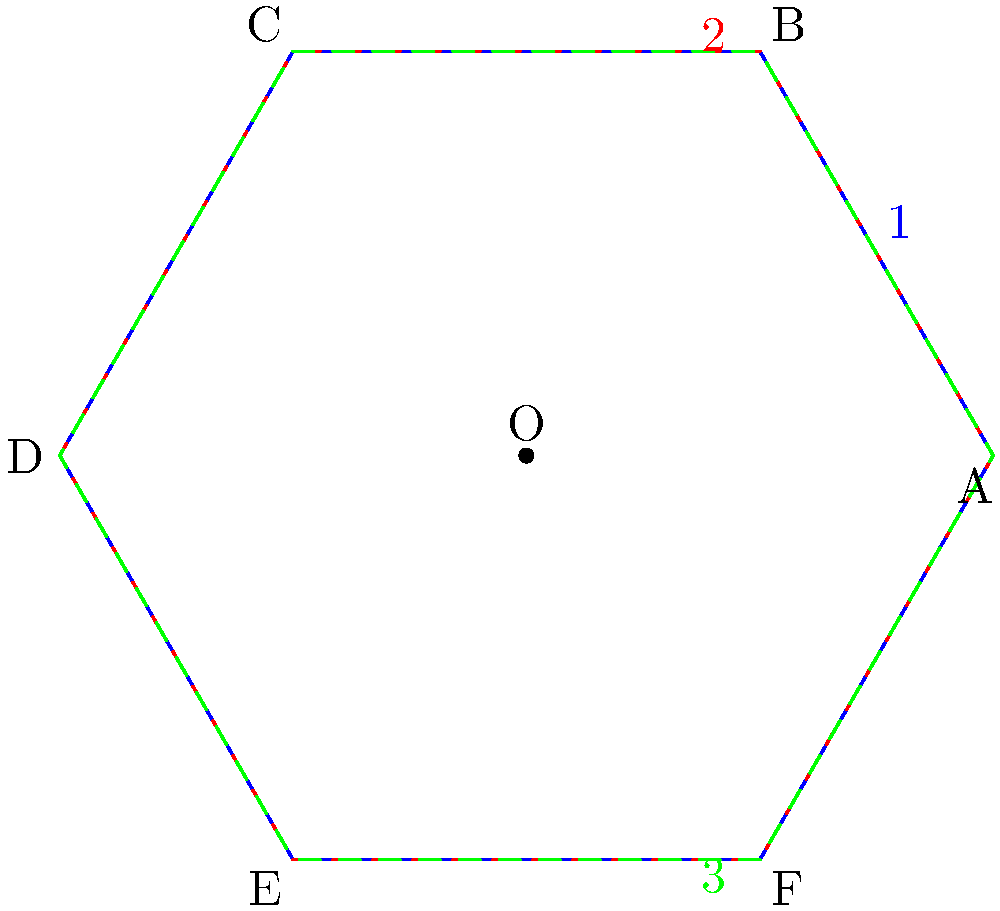A regular hexagon ABCDEF is centered at the origin O. It undergoes two successive transformations:
1. A 60° clockwise rotation about O
2. A reflection across the x-axis

What is the resulting transformation when these two are composed? Express your answer in terms of a single transformation about point O. Let's approach this step-by-step using the properties of transformational geometry:

1) First, we apply a 60° clockwise rotation about O. This is equivalent to a -60° (counterclockwise) rotation in standard notation.

2) Then, we apply a reflection across the x-axis.

3) To determine the composition of these transformations, we can use the following theorem: A rotation followed by a reflection is equivalent to a single reflection about a line that bisects the angle between the line of reflection and the rotated image of that line.

4) In this case:
   - The original line of reflection is the x-axis.
   - After a -60° rotation, the image of the x-axis makes a 60° angle with the positive x-axis.
   - The bisector of the 60° angle between these lines is at 30° to the x-axis.

5) Therefore, the composition of these two transformations is equivalent to a single reflection about a line passing through O at a 30° angle to the x-axis.

6) However, we can express this more succinctly. A reflection about a line through the center of a regular hexagon is equivalent to a rotation of 180° about the center, followed by a reflection across the line perpendicular to the original line of reflection.

7) In this case, that would be a 180° rotation followed by a reflection across a line at 120° to the x-axis (90° + 30°).

8) A 180° rotation followed by a reflection is equivalent to a rotation in the opposite direction by twice the angle between the reflection line and the x-axis.

9) The angle between the reflection line (120°) and the x-axis (0°) is 120°.

10) Therefore, the final single transformation is a rotation by -240° (or equivalently, 120° clockwise) about point O.
Answer: 120° clockwise rotation about O 